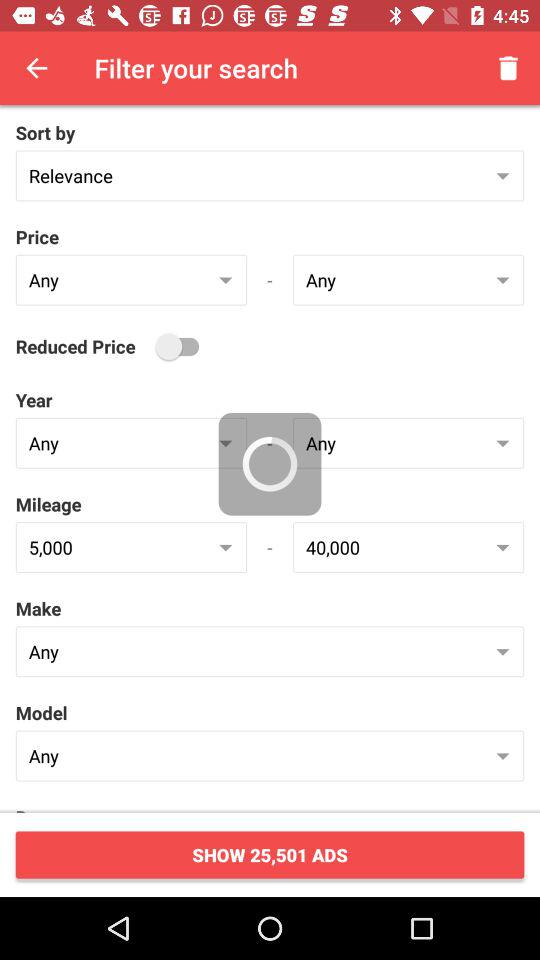What is the selected price range? The selected price range is from "Any" to "Any". 